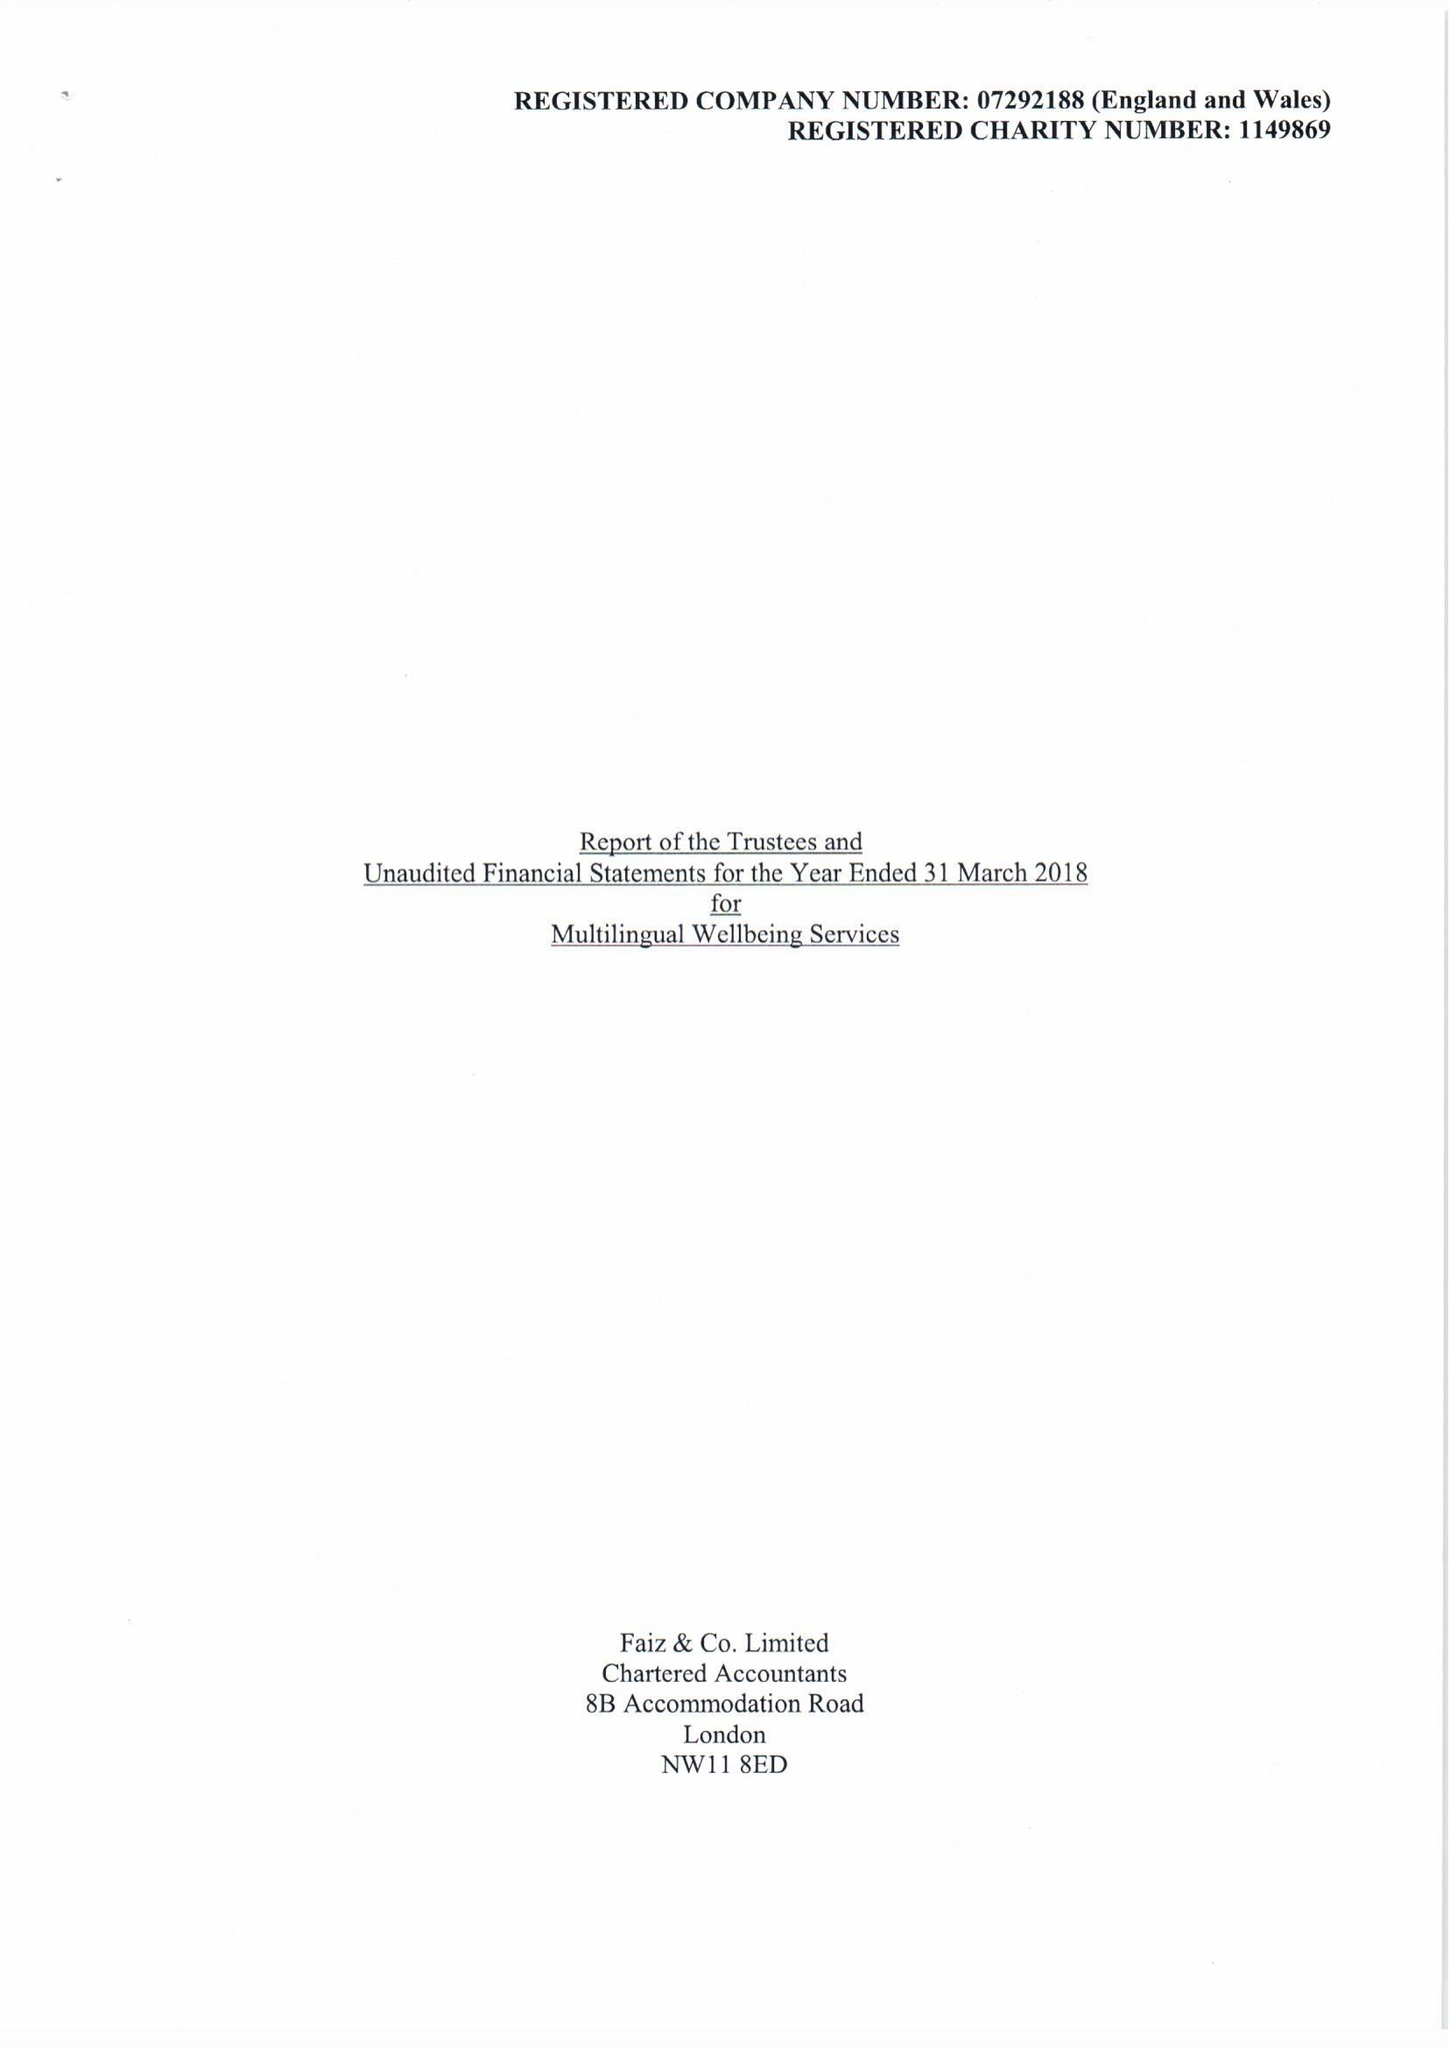What is the value for the income_annually_in_british_pounds?
Answer the question using a single word or phrase. 203963.00 